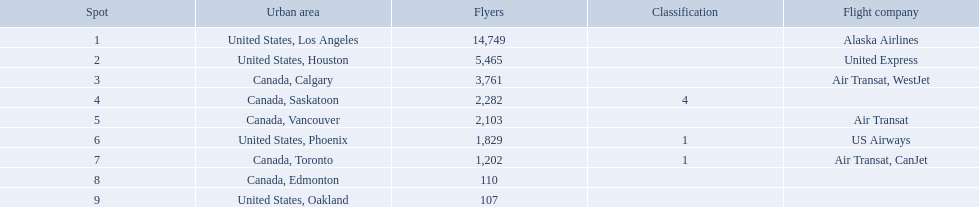Which airport has the least amount of passengers? 107. What airport has 107 passengers? United States, Oakland. What numbers are in the passengers column? 14,749, 5,465, 3,761, 2,282, 2,103, 1,829, 1,202, 110, 107. Which number is the lowest number in the passengers column? 107. What city is associated with this number? United States, Oakland. What are the cities flown to? United States, Los Angeles, United States, Houston, Canada, Calgary, Canada, Saskatoon, Canada, Vancouver, United States, Phoenix, Canada, Toronto, Canada, Edmonton, United States, Oakland. What number of passengers did pheonix have? 1,829. Where are the destinations of the airport? United States, Los Angeles, United States, Houston, Canada, Calgary, Canada, Saskatoon, Canada, Vancouver, United States, Phoenix, Canada, Toronto, Canada, Edmonton, United States, Oakland. What is the number of passengers to phoenix? 1,829. 